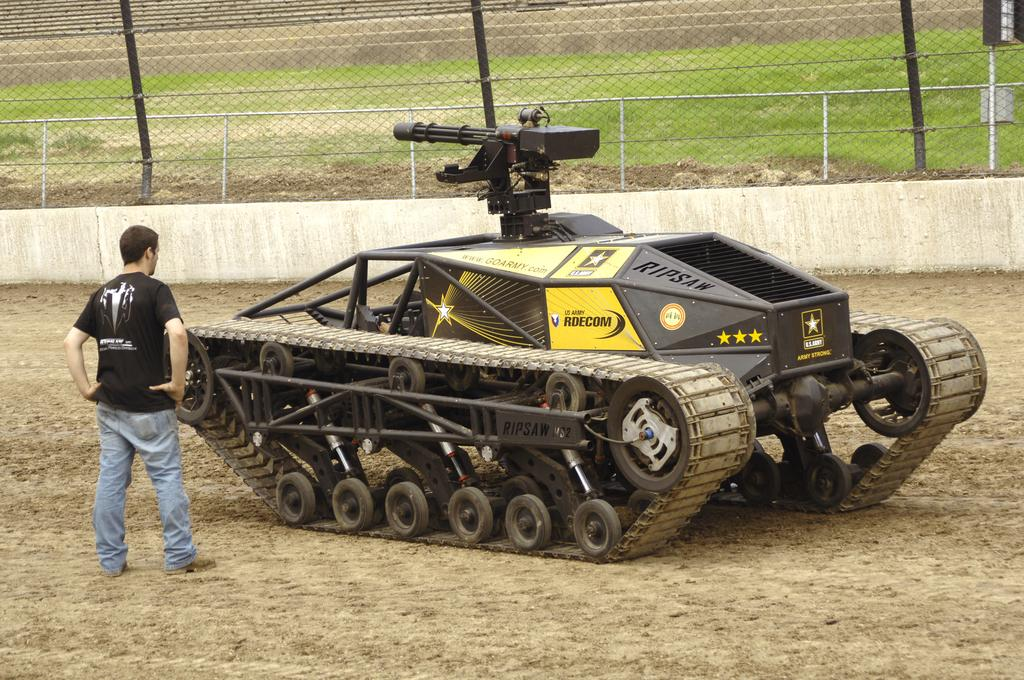What is the main subject in the image? There is a tanker in the image. Can you describe the person in the image? There is a person on the ground in the image. What type of barrier is present in the image? There is a fence in the image. What type of vegetation can be seen in the image? There is grass in the image. What object is used for separating or containing in the image? There is a net in the image. What type of lettuce is being used to shock the person in the image? There is no lettuce or shocking activity present in the image. 